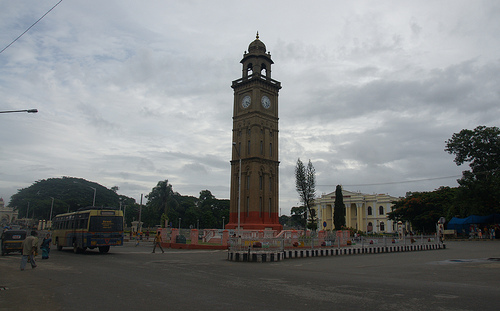Could you describe the weather in the image? The weather in the image appears overcast, with thick clouds covering most of the sky, suggesting it might be an early morning or a cloudy day where the possibility of rain could be imminent. Is there any indication of the time of day in the picture? Based on the clock tower, it appears to be around 10:10. However, without knowledge of the local time zone or daylight saving adjustments, we cannot determine the exact time of day definitively. 